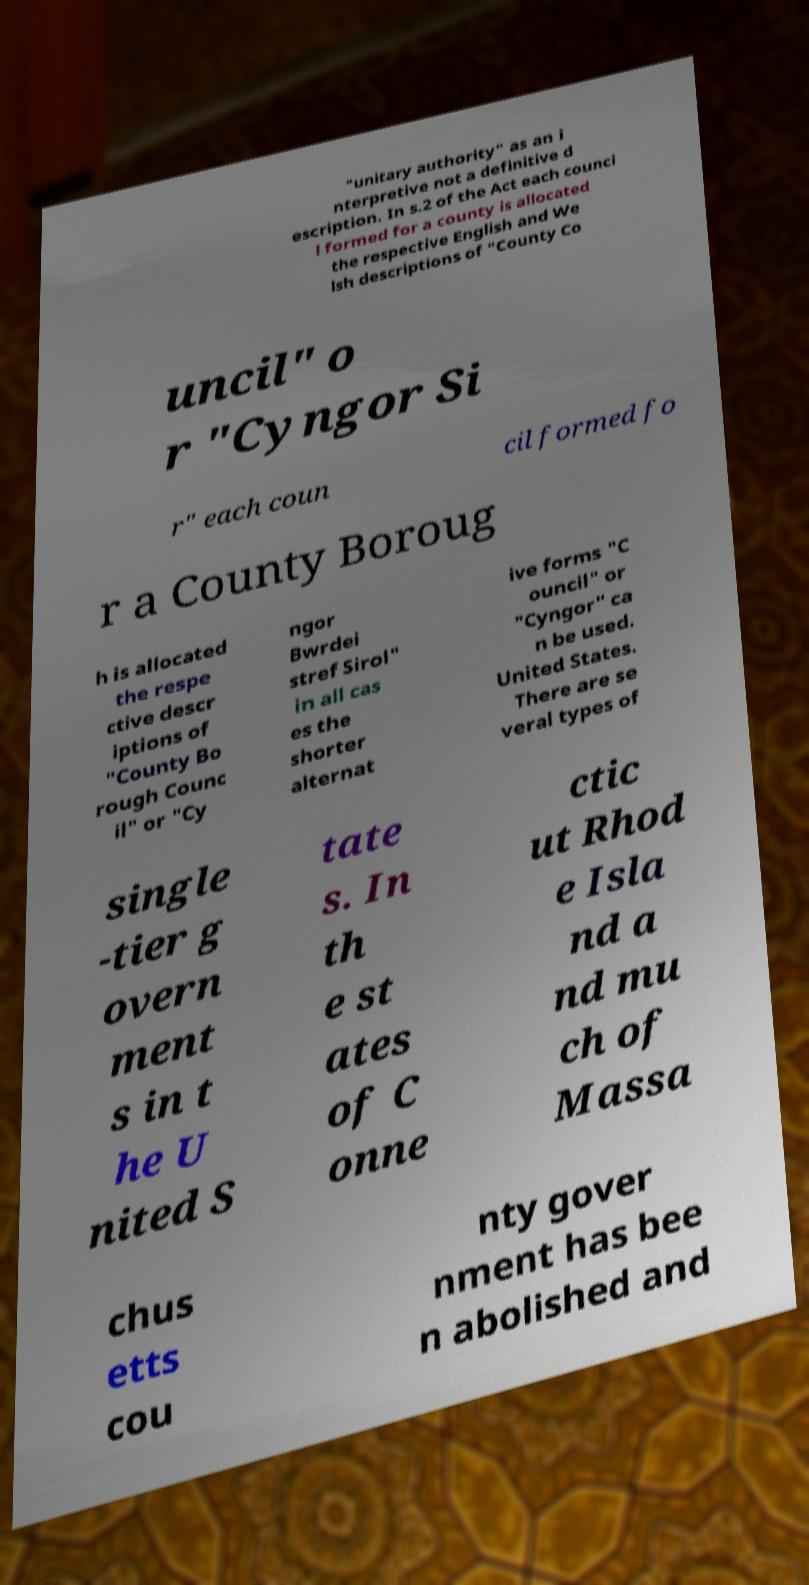Can you read and provide the text displayed in the image?This photo seems to have some interesting text. Can you extract and type it out for me? "unitary authority" as an i nterpretive not a definitive d escription. In s.2 of the Act each counci l formed for a county is allocated the respective English and We lsh descriptions of "County Co uncil" o r "Cyngor Si r" each coun cil formed fo r a County Boroug h is allocated the respe ctive descr iptions of "County Bo rough Counc il" or "Cy ngor Bwrdei stref Sirol" in all cas es the shorter alternat ive forms "C ouncil" or "Cyngor" ca n be used. United States. There are se veral types of single -tier g overn ment s in t he U nited S tate s. In th e st ates of C onne ctic ut Rhod e Isla nd a nd mu ch of Massa chus etts cou nty gover nment has bee n abolished and 